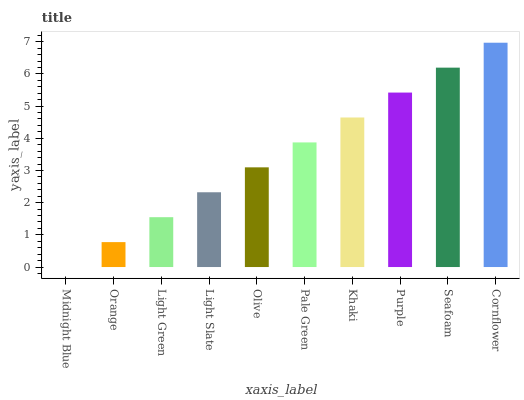Is Midnight Blue the minimum?
Answer yes or no. Yes. Is Cornflower the maximum?
Answer yes or no. Yes. Is Orange the minimum?
Answer yes or no. No. Is Orange the maximum?
Answer yes or no. No. Is Orange greater than Midnight Blue?
Answer yes or no. Yes. Is Midnight Blue less than Orange?
Answer yes or no. Yes. Is Midnight Blue greater than Orange?
Answer yes or no. No. Is Orange less than Midnight Blue?
Answer yes or no. No. Is Pale Green the high median?
Answer yes or no. Yes. Is Olive the low median?
Answer yes or no. Yes. Is Orange the high median?
Answer yes or no. No. Is Pale Green the low median?
Answer yes or no. No. 